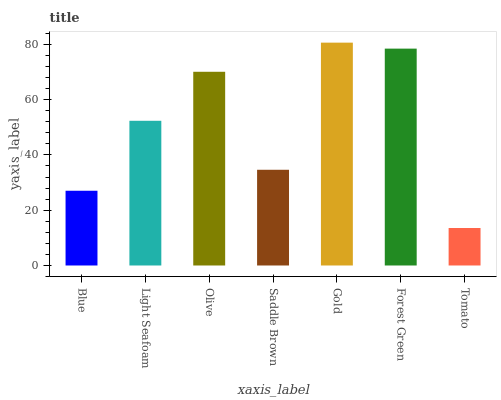Is Tomato the minimum?
Answer yes or no. Yes. Is Gold the maximum?
Answer yes or no. Yes. Is Light Seafoam the minimum?
Answer yes or no. No. Is Light Seafoam the maximum?
Answer yes or no. No. Is Light Seafoam greater than Blue?
Answer yes or no. Yes. Is Blue less than Light Seafoam?
Answer yes or no. Yes. Is Blue greater than Light Seafoam?
Answer yes or no. No. Is Light Seafoam less than Blue?
Answer yes or no. No. Is Light Seafoam the high median?
Answer yes or no. Yes. Is Light Seafoam the low median?
Answer yes or no. Yes. Is Tomato the high median?
Answer yes or no. No. Is Blue the low median?
Answer yes or no. No. 